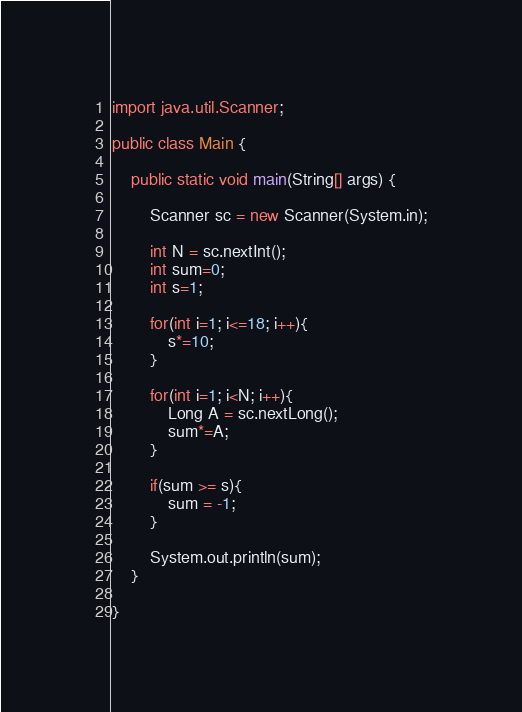Convert code to text. <code><loc_0><loc_0><loc_500><loc_500><_Java_>
import java.util.Scanner;

public class Main {

	public static void main(String[] args) {

		Scanner sc = new Scanner(System.in);

		int N = sc.nextInt();
		int sum=0;
		int s=1;
		
		for(int i=1; i<=18; i++){
			s*=10;
		}
		
		for(int i=1; i<N; i++){
			Long A = sc.nextLong();
			sum*=A;
		}
		
		if(sum >= s){
			sum = -1;
		}
		
		System.out.println(sum);
	}

}
</code> 